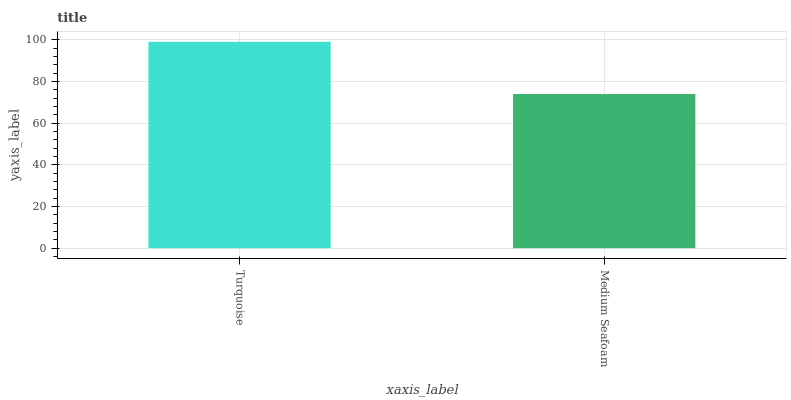Is Medium Seafoam the maximum?
Answer yes or no. No. Is Turquoise greater than Medium Seafoam?
Answer yes or no. Yes. Is Medium Seafoam less than Turquoise?
Answer yes or no. Yes. Is Medium Seafoam greater than Turquoise?
Answer yes or no. No. Is Turquoise less than Medium Seafoam?
Answer yes or no. No. Is Turquoise the high median?
Answer yes or no. Yes. Is Medium Seafoam the low median?
Answer yes or no. Yes. Is Medium Seafoam the high median?
Answer yes or no. No. Is Turquoise the low median?
Answer yes or no. No. 